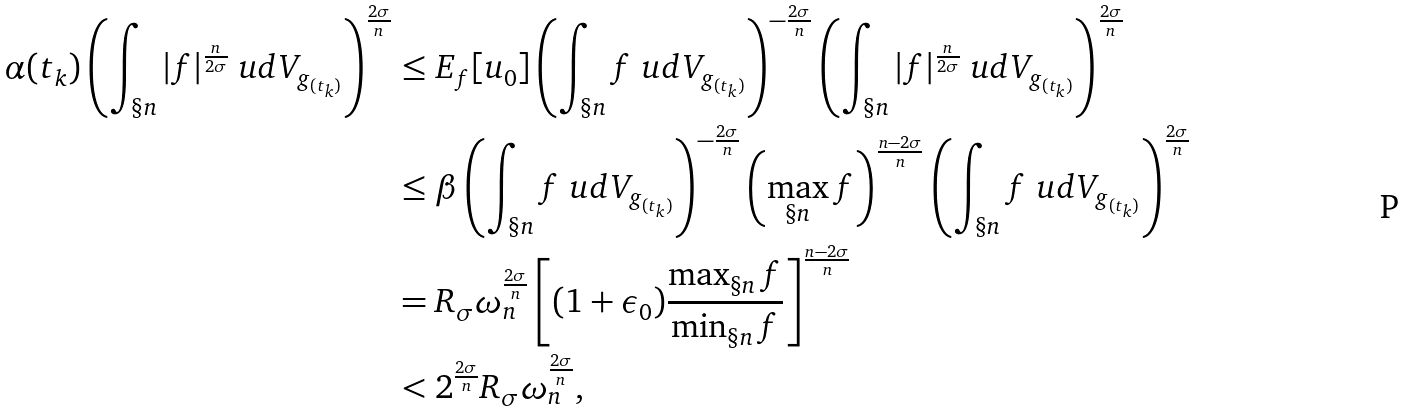<formula> <loc_0><loc_0><loc_500><loc_500>\alpha ( t _ { k } ) \left ( \int _ { \S n } | f | ^ { \frac { n } { 2 \sigma } } \ u d V _ { g _ { ( t _ { k } ) } } \right ) ^ { \frac { 2 \sigma } { n } } & \leq E _ { f } [ u _ { 0 } ] \left ( \int _ { \S n } f \ u d V _ { g _ { ( t _ { k } ) } } \right ) ^ { - \frac { 2 \sigma } { n } } \left ( \int _ { \S n } | f | ^ { \frac { n } { 2 \sigma } } \ u d V _ { g _ { ( t _ { k } ) } } \right ) ^ { \frac { 2 \sigma } { n } } \\ & \leq \beta \left ( \int _ { \S n } f \ u d V _ { g _ { ( t _ { k } ) } } \right ) ^ { - \frac { 2 \sigma } { n } } \left ( \max _ { \S n } f \right ) ^ { \frac { n - 2 \sigma } { n } } \left ( \int _ { \S n } f \ u d V _ { g _ { ( t _ { k } ) } } \right ) ^ { \frac { 2 \sigma } { n } } \\ & = R _ { \sigma } \omega _ { n } ^ { \frac { 2 \sigma } { n } } \left [ ( 1 + \epsilon _ { 0 } ) \frac { \max _ { \S n } f } { \min _ { \S n } f } \right ] ^ { \frac { n - 2 \sigma } { n } } \\ & < 2 ^ { \frac { 2 \sigma } { n } } R _ { \sigma } \omega _ { n } ^ { \frac { 2 \sigma } { n } } ,</formula> 